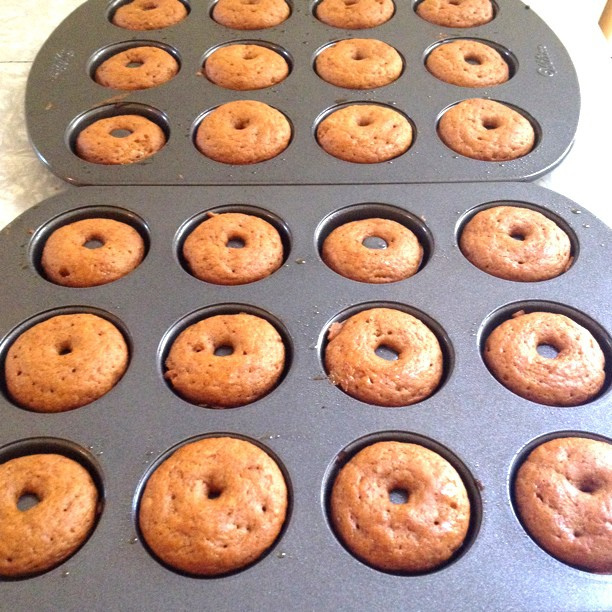What is the possible flavor of these donuts? They appear to be a classic flavor, possibly plain or vanilla, based on their golden brown color and lack of toppings or visible inclusions. Are these donuts suitable for people with gluten intolerance? It's not possible to confirm from the image alone if these are gluten-free. Ingredients and preparation method need to be known to determine that. 